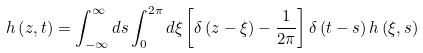<formula> <loc_0><loc_0><loc_500><loc_500>h \left ( z , t \right ) = \int _ { - \infty } ^ { \infty } d s \int _ { 0 } ^ { 2 \pi } d \xi \left [ \delta \left ( z - \xi \right ) - \frac { 1 } { 2 \pi } \right ] \delta \left ( t - s \right ) h \left ( \xi , s \right )</formula> 